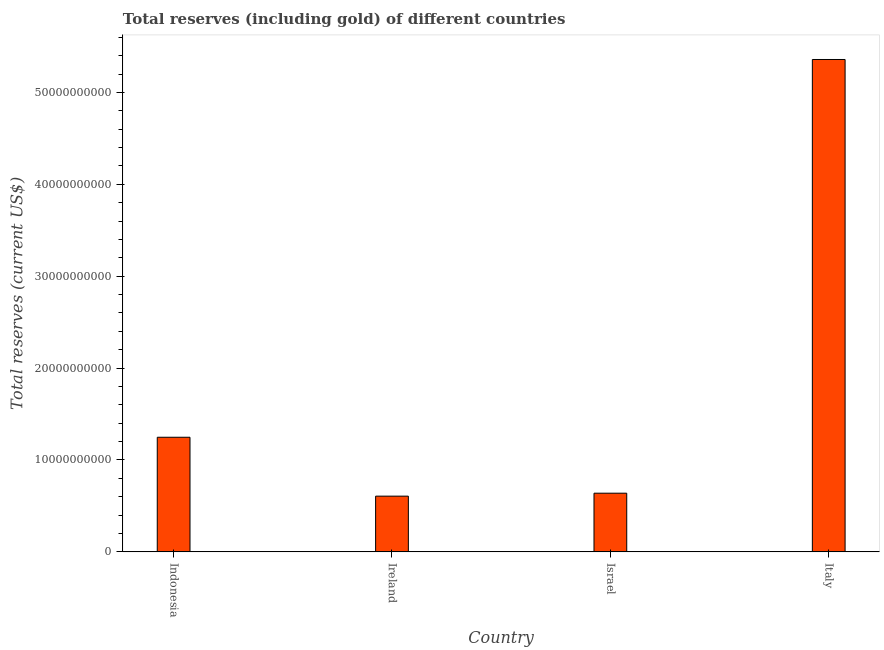What is the title of the graph?
Give a very brief answer. Total reserves (including gold) of different countries. What is the label or title of the Y-axis?
Keep it short and to the point. Total reserves (current US$). What is the total reserves (including gold) in Israel?
Provide a succinct answer. 6.39e+09. Across all countries, what is the maximum total reserves (including gold)?
Provide a succinct answer. 5.36e+1. Across all countries, what is the minimum total reserves (including gold)?
Offer a very short reply. 6.07e+09. In which country was the total reserves (including gold) maximum?
Offer a terse response. Italy. In which country was the total reserves (including gold) minimum?
Offer a very short reply. Ireland. What is the sum of the total reserves (including gold)?
Ensure brevity in your answer.  7.85e+1. What is the difference between the total reserves (including gold) in Indonesia and Italy?
Your answer should be compact. -4.11e+1. What is the average total reserves (including gold) per country?
Provide a short and direct response. 1.96e+1. What is the median total reserves (including gold)?
Keep it short and to the point. 9.43e+09. In how many countries, is the total reserves (including gold) greater than 46000000000 US$?
Ensure brevity in your answer.  1. What is the difference between the highest and the second highest total reserves (including gold)?
Provide a succinct answer. 4.11e+1. Is the sum of the total reserves (including gold) in Indonesia and Italy greater than the maximum total reserves (including gold) across all countries?
Keep it short and to the point. Yes. What is the difference between the highest and the lowest total reserves (including gold)?
Give a very brief answer. 4.75e+1. How many bars are there?
Your answer should be compact. 4. Are the values on the major ticks of Y-axis written in scientific E-notation?
Make the answer very short. No. What is the Total reserves (current US$) in Indonesia?
Your answer should be very brief. 1.25e+1. What is the Total reserves (current US$) in Ireland?
Make the answer very short. 6.07e+09. What is the Total reserves (current US$) of Israel?
Make the answer very short. 6.39e+09. What is the Total reserves (current US$) of Italy?
Provide a succinct answer. 5.36e+1. What is the difference between the Total reserves (current US$) in Indonesia and Ireland?
Make the answer very short. 6.41e+09. What is the difference between the Total reserves (current US$) in Indonesia and Israel?
Your answer should be compact. 6.09e+09. What is the difference between the Total reserves (current US$) in Indonesia and Italy?
Offer a very short reply. -4.11e+1. What is the difference between the Total reserves (current US$) in Ireland and Israel?
Your answer should be very brief. -3.20e+08. What is the difference between the Total reserves (current US$) in Ireland and Italy?
Make the answer very short. -4.75e+1. What is the difference between the Total reserves (current US$) in Israel and Italy?
Ensure brevity in your answer.  -4.72e+1. What is the ratio of the Total reserves (current US$) in Indonesia to that in Ireland?
Your response must be concise. 2.06. What is the ratio of the Total reserves (current US$) in Indonesia to that in Israel?
Offer a very short reply. 1.95. What is the ratio of the Total reserves (current US$) in Indonesia to that in Italy?
Your answer should be very brief. 0.23. What is the ratio of the Total reserves (current US$) in Ireland to that in Israel?
Provide a succinct answer. 0.95. What is the ratio of the Total reserves (current US$) in Ireland to that in Italy?
Ensure brevity in your answer.  0.11. What is the ratio of the Total reserves (current US$) in Israel to that in Italy?
Your answer should be compact. 0.12. 